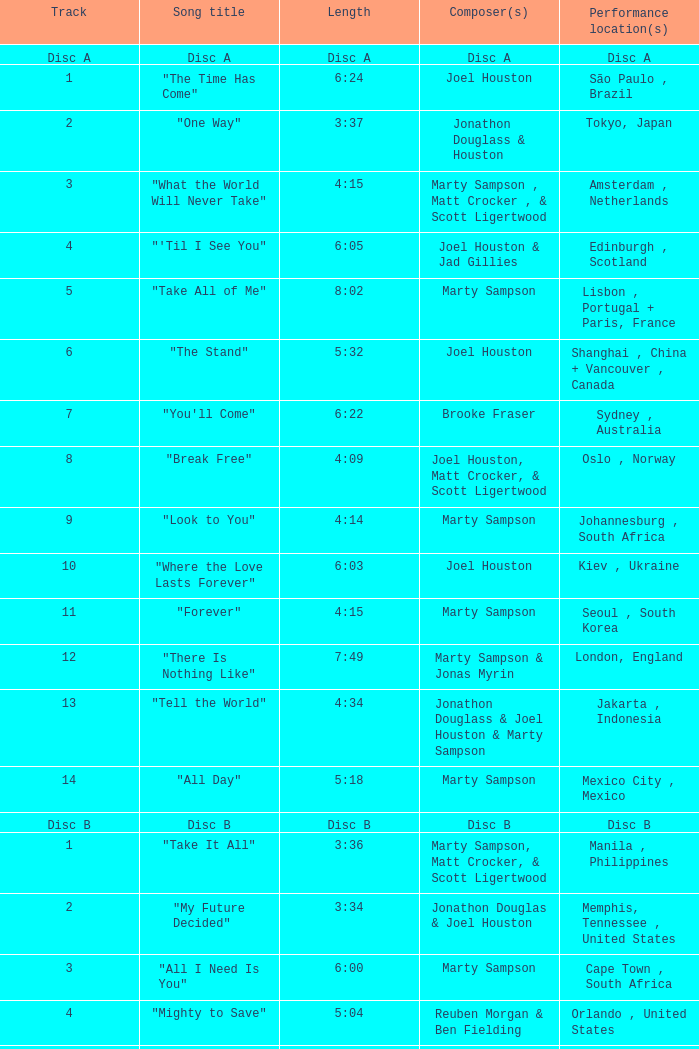Which composer created the 6:24 long track? Joel Houston. 